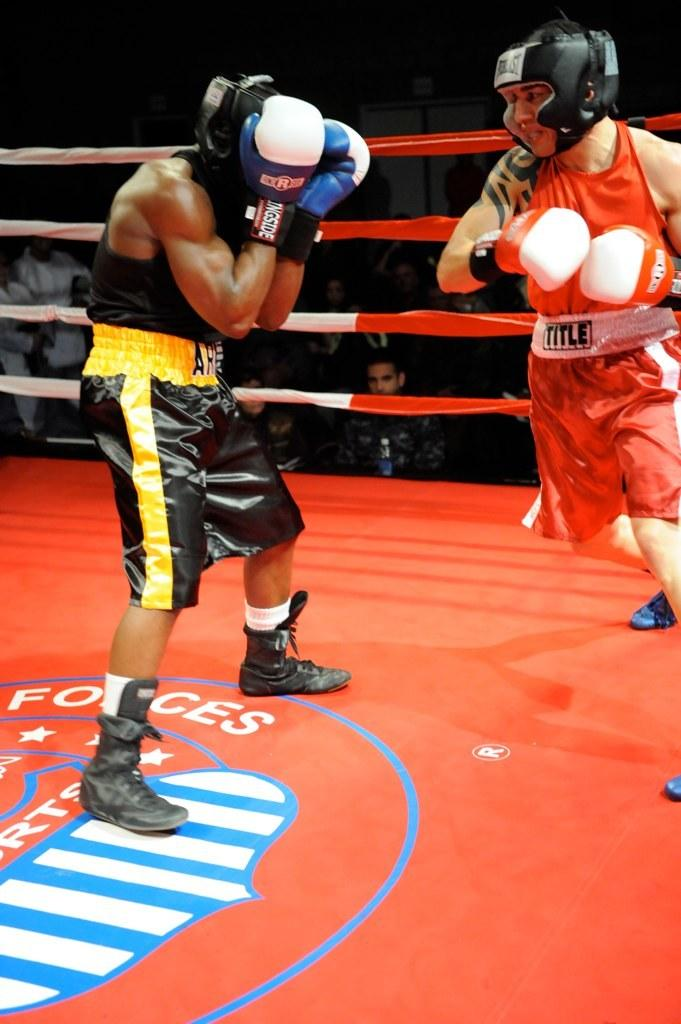<image>
Offer a succinct explanation of the picture presented. Two men boxing including one in red with shorts reading TITLE. 